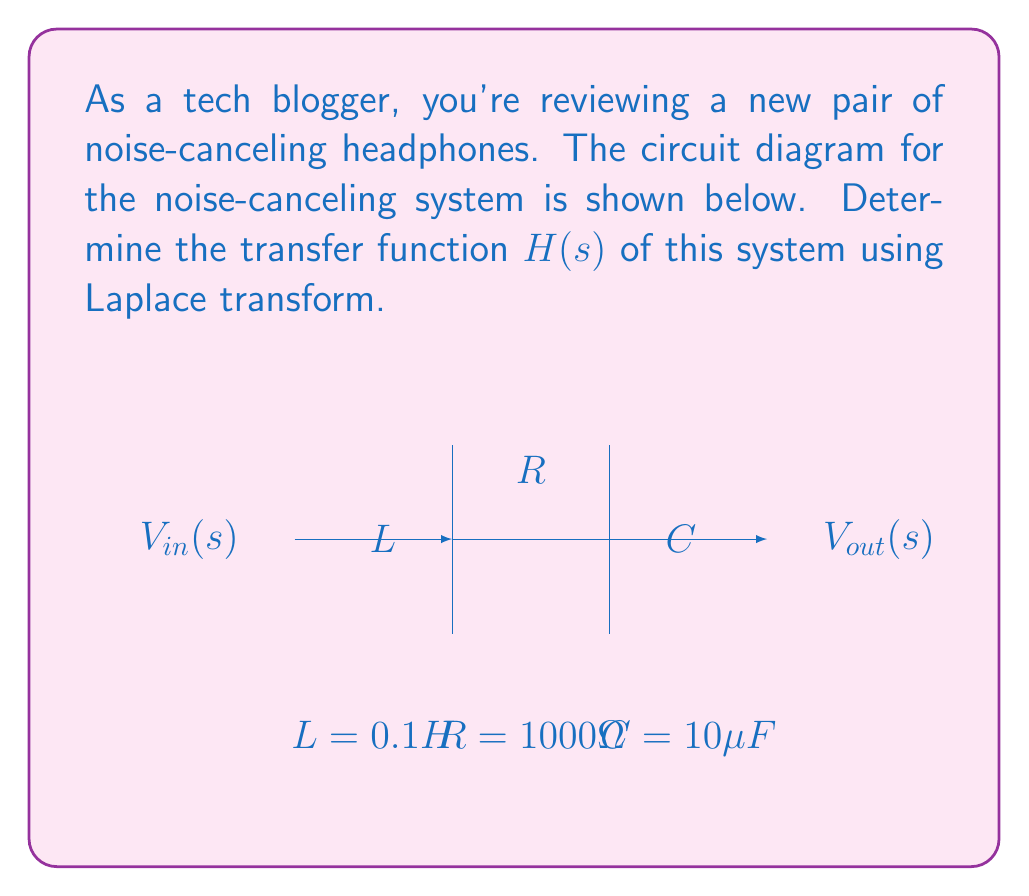Could you help me with this problem? To find the transfer function $H(s)$ of the noise-canceling headphone circuit, we'll follow these steps:

1) The transfer function is defined as the ratio of output to input in the s-domain:

   $$H(s) = \frac{V_{out}(s)}{V_{in}(s)}$$

2) In this RLC circuit, we have:
   - Resistor: $R = 1000\Omega$
   - Inductor: $L = 0.1H$
   - Capacitor: $C = 10\mu F = 10 \times 10^{-6}F$

3) The impedance of each component in the s-domain is:
   - Resistor: $Z_R = R = 1000$
   - Inductor: $Z_L = sL = 0.1s$
   - Capacitor: $Z_C = \frac{1}{sC} = \frac{1}{10 \times 10^{-6}s} = \frac{10^5}{s}$

4) The total impedance of the circuit is the sum of these impedances:

   $$Z_{total} = Z_R + Z_L + Z_C = 1000 + 0.1s + \frac{10^5}{s}$$

5) The transfer function is the ratio of the capacitor's impedance to the total impedance:

   $$H(s) = \frac{Z_C}{Z_{total}} = \frac{\frac{10^5}{s}}{1000 + 0.1s + \frac{10^5}{s}}$$

6) Simplify by multiplying numerator and denominator by s:

   $$H(s) = \frac{10^5}{1000s + 0.1s^2 + 10^5}$$

7) Divide all terms by $10^5$ to normalize:

   $$H(s) = \frac{1}{0.01s + 10^{-6}s^2 + 1}$$

This is the final form of the transfer function for the noise-canceling headphone circuit.
Answer: $$H(s) = \frac{1}{0.01s + 10^{-6}s^2 + 1}$$ 